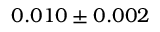Convert formula to latex. <formula><loc_0><loc_0><loc_500><loc_500>0 . 0 1 0 \pm 0 . 0 0 2</formula> 